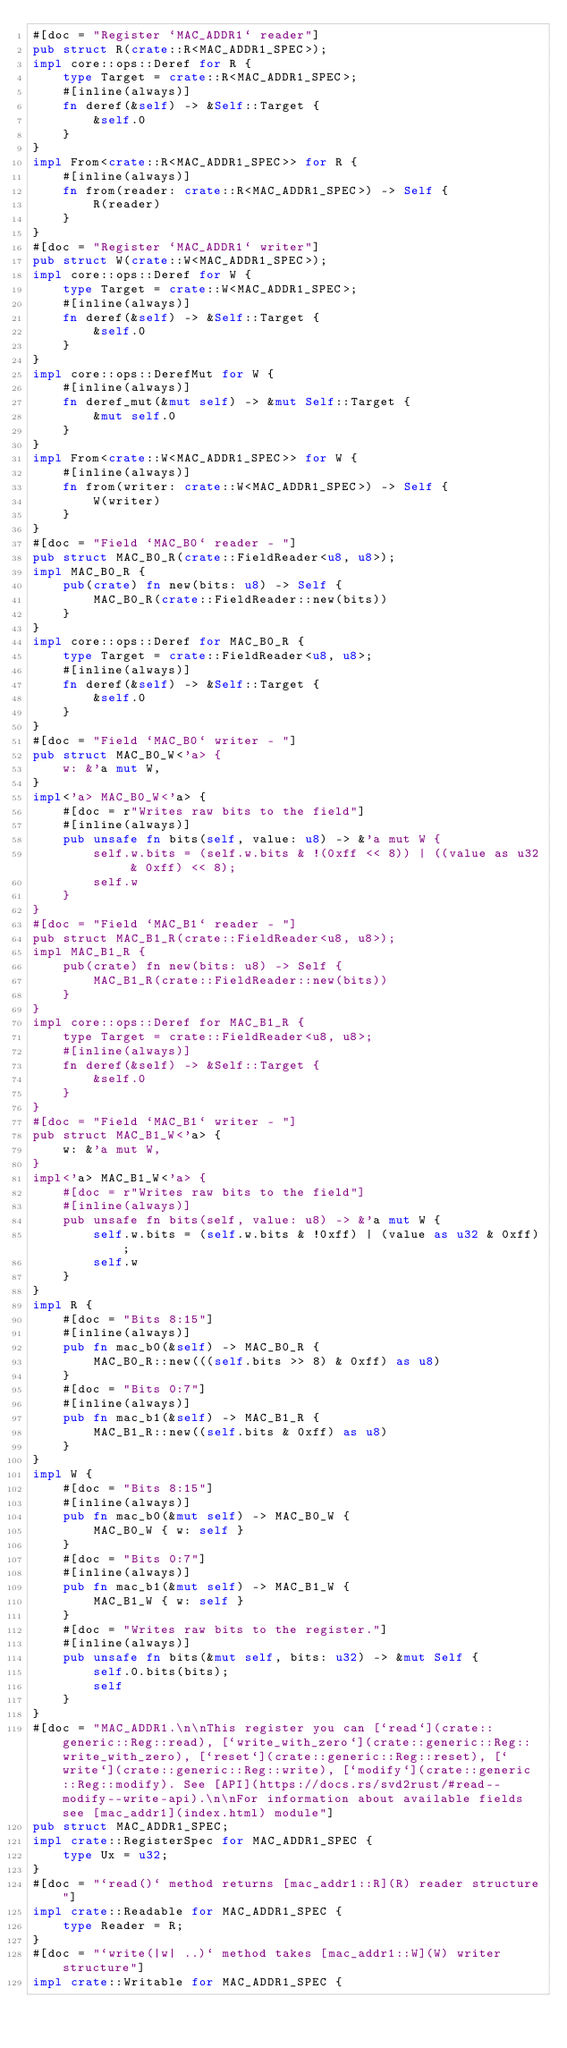<code> <loc_0><loc_0><loc_500><loc_500><_Rust_>#[doc = "Register `MAC_ADDR1` reader"]
pub struct R(crate::R<MAC_ADDR1_SPEC>);
impl core::ops::Deref for R {
    type Target = crate::R<MAC_ADDR1_SPEC>;
    #[inline(always)]
    fn deref(&self) -> &Self::Target {
        &self.0
    }
}
impl From<crate::R<MAC_ADDR1_SPEC>> for R {
    #[inline(always)]
    fn from(reader: crate::R<MAC_ADDR1_SPEC>) -> Self {
        R(reader)
    }
}
#[doc = "Register `MAC_ADDR1` writer"]
pub struct W(crate::W<MAC_ADDR1_SPEC>);
impl core::ops::Deref for W {
    type Target = crate::W<MAC_ADDR1_SPEC>;
    #[inline(always)]
    fn deref(&self) -> &Self::Target {
        &self.0
    }
}
impl core::ops::DerefMut for W {
    #[inline(always)]
    fn deref_mut(&mut self) -> &mut Self::Target {
        &mut self.0
    }
}
impl From<crate::W<MAC_ADDR1_SPEC>> for W {
    #[inline(always)]
    fn from(writer: crate::W<MAC_ADDR1_SPEC>) -> Self {
        W(writer)
    }
}
#[doc = "Field `MAC_B0` reader - "]
pub struct MAC_B0_R(crate::FieldReader<u8, u8>);
impl MAC_B0_R {
    pub(crate) fn new(bits: u8) -> Self {
        MAC_B0_R(crate::FieldReader::new(bits))
    }
}
impl core::ops::Deref for MAC_B0_R {
    type Target = crate::FieldReader<u8, u8>;
    #[inline(always)]
    fn deref(&self) -> &Self::Target {
        &self.0
    }
}
#[doc = "Field `MAC_B0` writer - "]
pub struct MAC_B0_W<'a> {
    w: &'a mut W,
}
impl<'a> MAC_B0_W<'a> {
    #[doc = r"Writes raw bits to the field"]
    #[inline(always)]
    pub unsafe fn bits(self, value: u8) -> &'a mut W {
        self.w.bits = (self.w.bits & !(0xff << 8)) | ((value as u32 & 0xff) << 8);
        self.w
    }
}
#[doc = "Field `MAC_B1` reader - "]
pub struct MAC_B1_R(crate::FieldReader<u8, u8>);
impl MAC_B1_R {
    pub(crate) fn new(bits: u8) -> Self {
        MAC_B1_R(crate::FieldReader::new(bits))
    }
}
impl core::ops::Deref for MAC_B1_R {
    type Target = crate::FieldReader<u8, u8>;
    #[inline(always)]
    fn deref(&self) -> &Self::Target {
        &self.0
    }
}
#[doc = "Field `MAC_B1` writer - "]
pub struct MAC_B1_W<'a> {
    w: &'a mut W,
}
impl<'a> MAC_B1_W<'a> {
    #[doc = r"Writes raw bits to the field"]
    #[inline(always)]
    pub unsafe fn bits(self, value: u8) -> &'a mut W {
        self.w.bits = (self.w.bits & !0xff) | (value as u32 & 0xff);
        self.w
    }
}
impl R {
    #[doc = "Bits 8:15"]
    #[inline(always)]
    pub fn mac_b0(&self) -> MAC_B0_R {
        MAC_B0_R::new(((self.bits >> 8) & 0xff) as u8)
    }
    #[doc = "Bits 0:7"]
    #[inline(always)]
    pub fn mac_b1(&self) -> MAC_B1_R {
        MAC_B1_R::new((self.bits & 0xff) as u8)
    }
}
impl W {
    #[doc = "Bits 8:15"]
    #[inline(always)]
    pub fn mac_b0(&mut self) -> MAC_B0_W {
        MAC_B0_W { w: self }
    }
    #[doc = "Bits 0:7"]
    #[inline(always)]
    pub fn mac_b1(&mut self) -> MAC_B1_W {
        MAC_B1_W { w: self }
    }
    #[doc = "Writes raw bits to the register."]
    #[inline(always)]
    pub unsafe fn bits(&mut self, bits: u32) -> &mut Self {
        self.0.bits(bits);
        self
    }
}
#[doc = "MAC_ADDR1.\n\nThis register you can [`read`](crate::generic::Reg::read), [`write_with_zero`](crate::generic::Reg::write_with_zero), [`reset`](crate::generic::Reg::reset), [`write`](crate::generic::Reg::write), [`modify`](crate::generic::Reg::modify). See [API](https://docs.rs/svd2rust/#read--modify--write-api).\n\nFor information about available fields see [mac_addr1](index.html) module"]
pub struct MAC_ADDR1_SPEC;
impl crate::RegisterSpec for MAC_ADDR1_SPEC {
    type Ux = u32;
}
#[doc = "`read()` method returns [mac_addr1::R](R) reader structure"]
impl crate::Readable for MAC_ADDR1_SPEC {
    type Reader = R;
}
#[doc = "`write(|w| ..)` method takes [mac_addr1::W](W) writer structure"]
impl crate::Writable for MAC_ADDR1_SPEC {</code> 